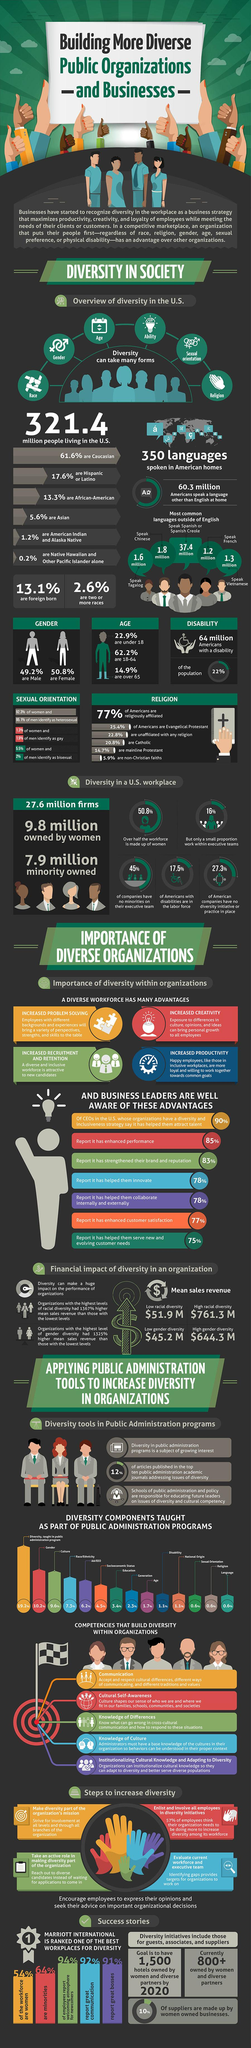Highlight a few significant elements in this photo. According to recent statistics, approximately 17.5% of Americans have disabilities and are currently participating in the workforce. Tagalog is a language spoken by approximately 1.6 million people in their homes in the United States. According to recent data, approximately 50.8% of the US workforce is composed of women. According to data, 37.4 million people in the US speak Spanish or Spanish Creole at home. A diverse workforce that includes individuals from a range of backgrounds and experiences has the advantage of increased productivity and creativity. 